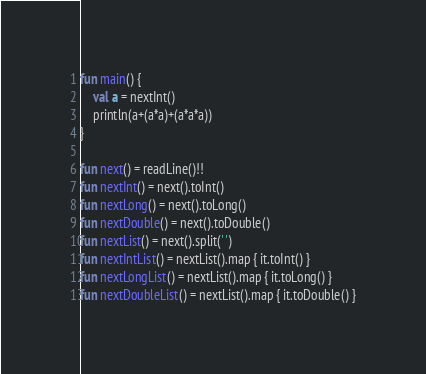Convert code to text. <code><loc_0><loc_0><loc_500><loc_500><_Kotlin_>fun main() {
    val a = nextInt()
    println(a+(a*a)+(a*a*a))
}

fun next() = readLine()!!
fun nextInt() = next().toInt()
fun nextLong() = next().toLong()
fun nextDouble() = next().toDouble()
fun nextList() = next().split(' ')
fun nextIntList() = nextList().map { it.toInt() }
fun nextLongList() = nextList().map { it.toLong() }
fun nextDoubleList() = nextList().map { it.toDouble() }
</code> 